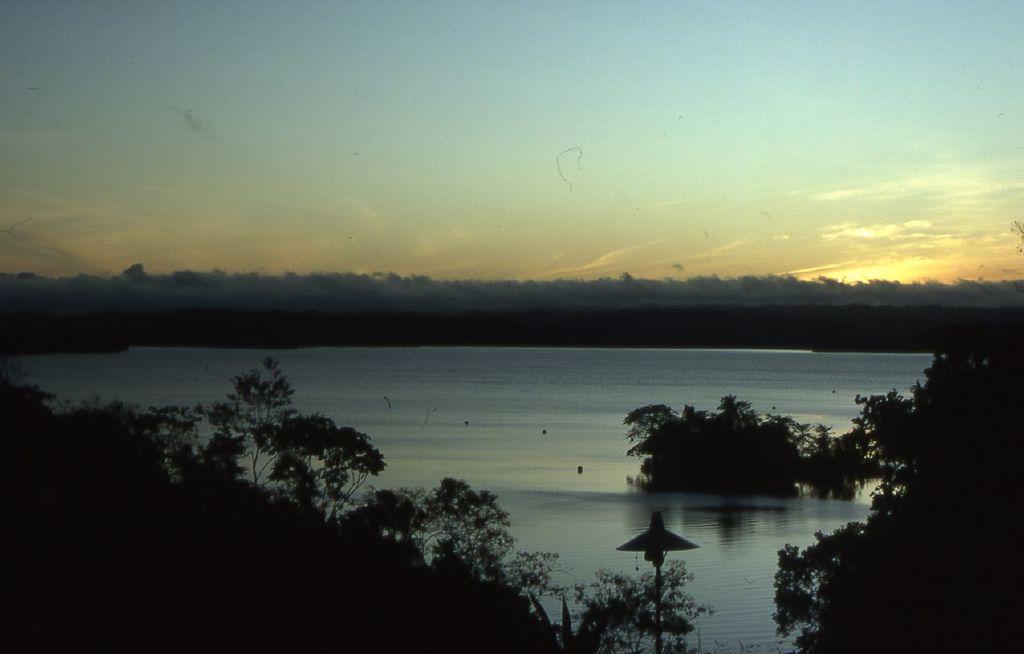In one or two sentences, can you explain what this image depicts? In this picture we can see water and trees, here we can see an object and we can see sky in the background. 